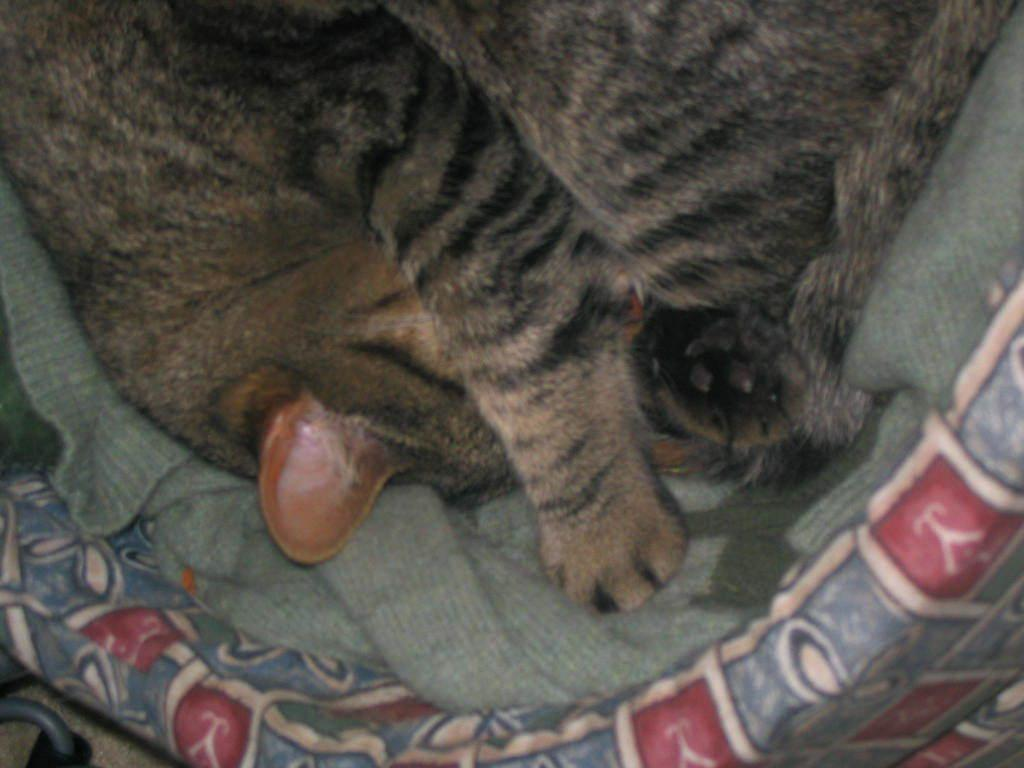What type of creature is in the image? There is an animal in the image. How is the animal positioned in the image? The animal is in a blanket. What is the blanket placed on in the image? The blanket is placed on an object that looks like a bed. What type of bird can be seen flying over the train at night in the image? There is no bird, train, or nighttime setting depicted in the image. The image features an animal in a blanket on an object that looks like a bed. 